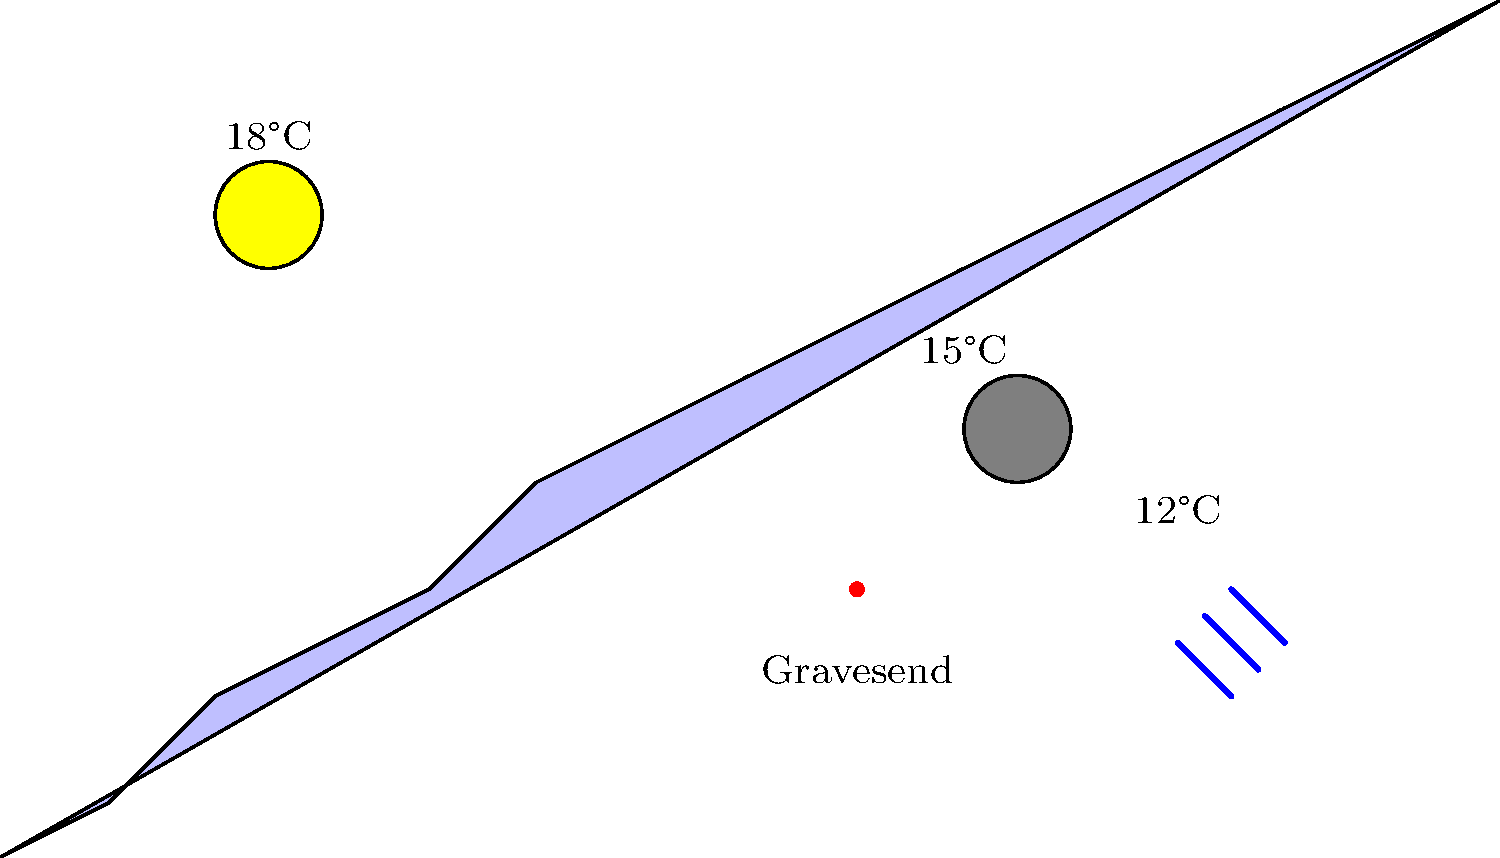Based on the weather forecast map of the UK, what is the expected weather condition in Gravesend? To determine the expected weather condition in Gravesend, we need to follow these steps:

1. Locate Gravesend on the map:
   - Gravesend is marked with a red dot on the map.

2. Observe the weather symbols near Gravesend:
   - To the west (left) of Gravesend, we see a sun symbol.
   - To the east (right) of Gravesend, we see a cloud symbol.
   - Further east, we see rain symbols.

3. Analyze the temperature gradient:
   - The temperature decreases from west to east.
   - Gravesend is between the 18°C and 15°C labels.

4. Interpret the weather pattern:
   - The map suggests a weather front moving from west to east.
   - Gravesend is in a transition zone between sunny and cloudy conditions.

5. Conclude the expected weather:
   - Given Gravesend's position between sunny and cloudy areas, it's likely to experience partly cloudy conditions.
   - The temperature in Gravesend is estimated to be around 16-17°C, based on its location between the 18°C and 15°C labels.

Therefore, the expected weather condition in Gravesend is partly cloudy with a temperature of approximately 16-17°C.
Answer: Partly cloudy, ~16-17°C 